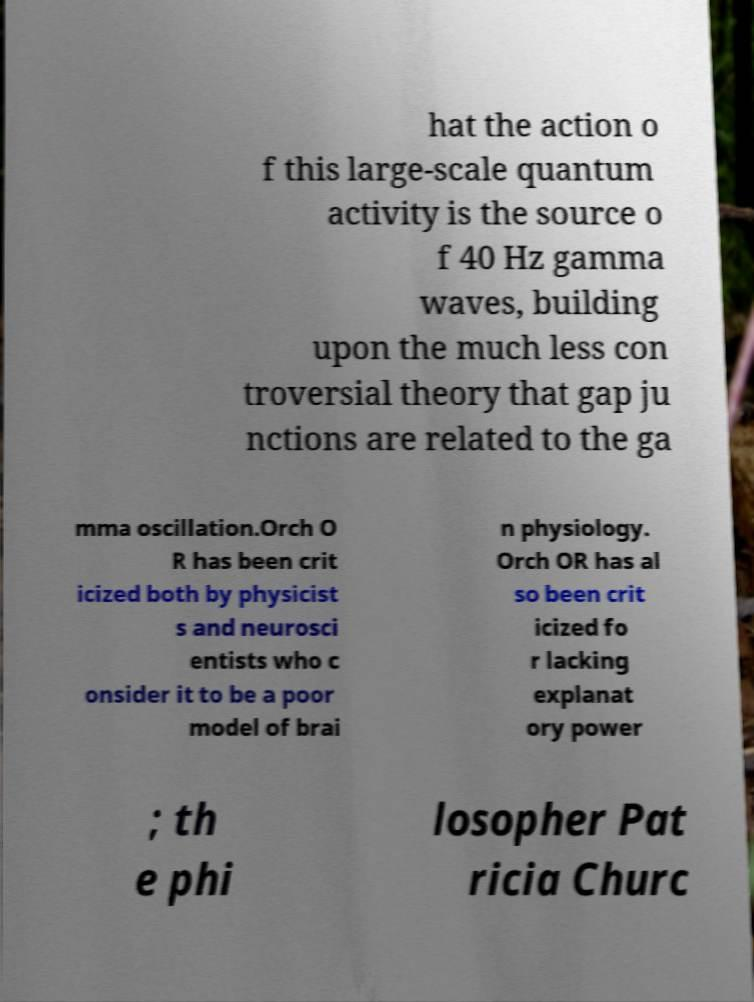Please identify and transcribe the text found in this image. hat the action o f this large-scale quantum activity is the source o f 40 Hz gamma waves, building upon the much less con troversial theory that gap ju nctions are related to the ga mma oscillation.Orch O R has been crit icized both by physicist s and neurosci entists who c onsider it to be a poor model of brai n physiology. Orch OR has al so been crit icized fo r lacking explanat ory power ; th e phi losopher Pat ricia Churc 